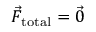Convert formula to latex. <formula><loc_0><loc_0><loc_500><loc_500>\vec { F } _ { t o t a l } = \vec { 0 }</formula> 